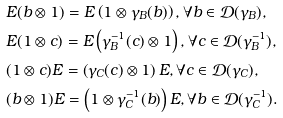<formula> <loc_0><loc_0><loc_500><loc_500>& E ( b \otimes 1 ) = E \left ( 1 \otimes \gamma _ { B } ( b ) \right ) , \forall b \in { \mathcal { D } } ( \gamma _ { B } ) , \\ & E ( 1 \otimes c ) = E \left ( \gamma _ { B } ^ { - 1 } ( c ) \otimes 1 \right ) , \forall c \in { \mathcal { D } } ( \gamma _ { B } ^ { - 1 } ) , \\ & ( 1 \otimes c ) E = \left ( \gamma _ { C } ( c ) \otimes 1 \right ) E , \forall c \in { \mathcal { D } } ( \gamma _ { C } ) , \\ & ( b \otimes 1 ) E = \left ( 1 \otimes \gamma _ { C } ^ { - 1 } ( b ) \right ) E , \forall b \in { \mathcal { D } } ( \gamma _ { C } ^ { - 1 } ) .</formula> 